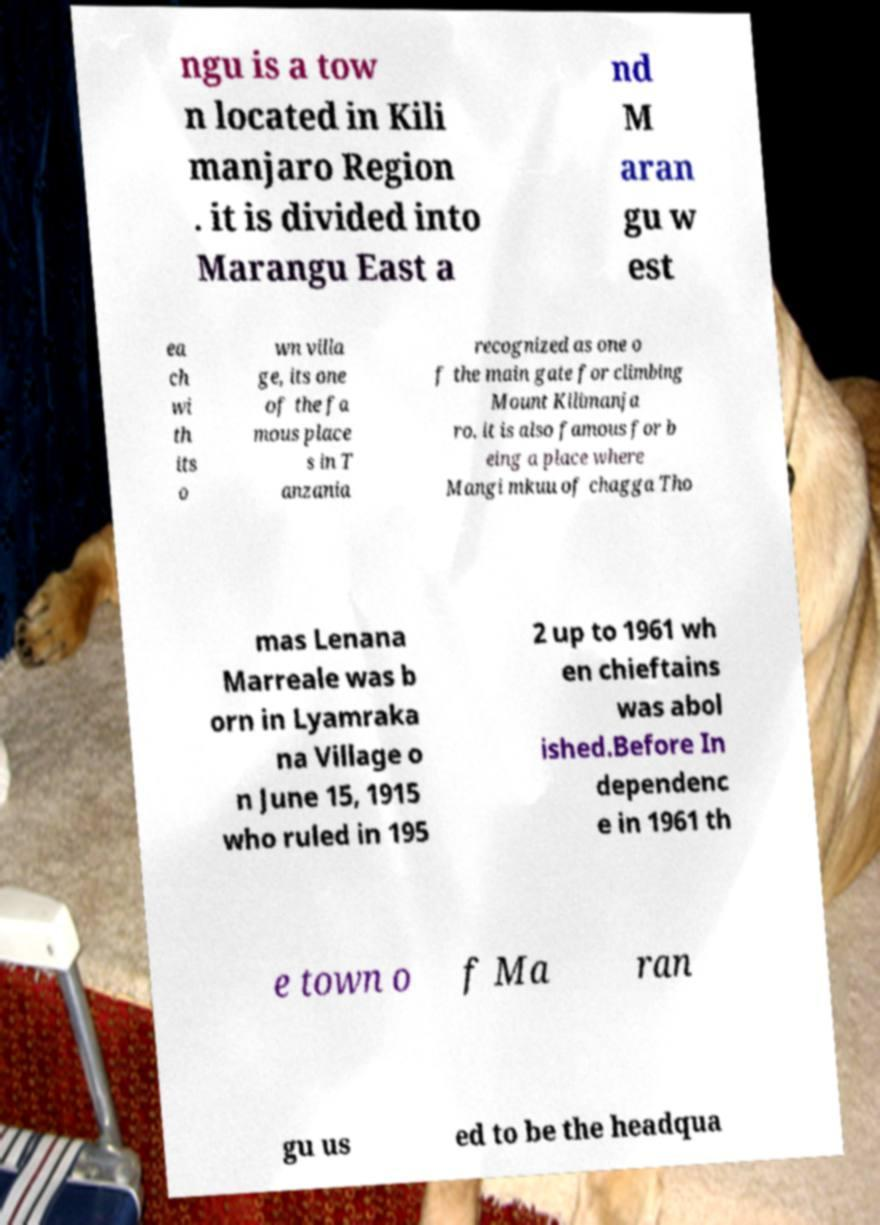I need the written content from this picture converted into text. Can you do that? ngu is a tow n located in Kili manjaro Region . it is divided into Marangu East a nd M aran gu w est ea ch wi th its o wn villa ge, its one of the fa mous place s in T anzania recognized as one o f the main gate for climbing Mount Kilimanja ro. it is also famous for b eing a place where Mangi mkuu of chagga Tho mas Lenana Marreale was b orn in Lyamraka na Village o n June 15, 1915 who ruled in 195 2 up to 1961 wh en chieftains was abol ished.Before In dependenc e in 1961 th e town o f Ma ran gu us ed to be the headqua 